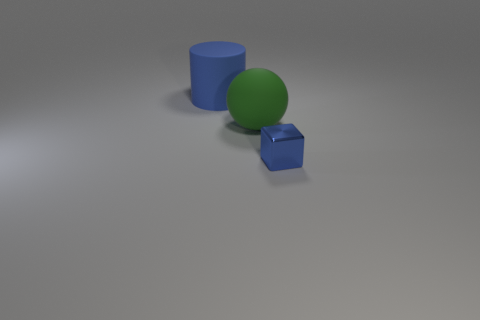Add 2 big green rubber objects. How many objects exist? 5 Subtract all cylinders. How many objects are left? 2 Add 3 rubber objects. How many rubber objects are left? 5 Add 1 tiny yellow rubber cubes. How many tiny yellow rubber cubes exist? 1 Subtract 0 blue spheres. How many objects are left? 3 Subtract 1 balls. How many balls are left? 0 Subtract all yellow blocks. Subtract all yellow balls. How many blocks are left? 1 Subtract all metal blocks. Subtract all large green things. How many objects are left? 1 